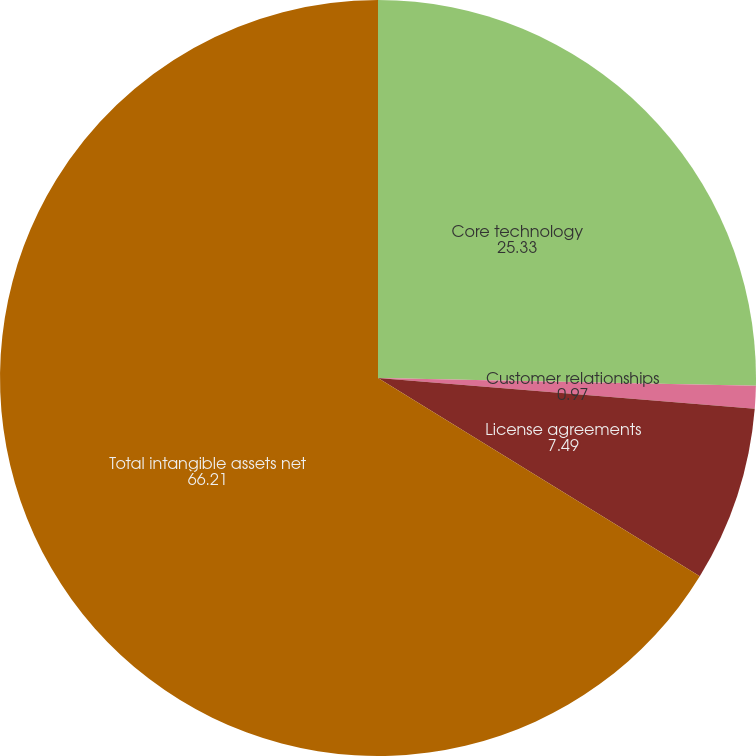Convert chart to OTSL. <chart><loc_0><loc_0><loc_500><loc_500><pie_chart><fcel>Core technology<fcel>Customer relationships<fcel>License agreements<fcel>Total intangible assets net<nl><fcel>25.33%<fcel>0.97%<fcel>7.49%<fcel>66.21%<nl></chart> 